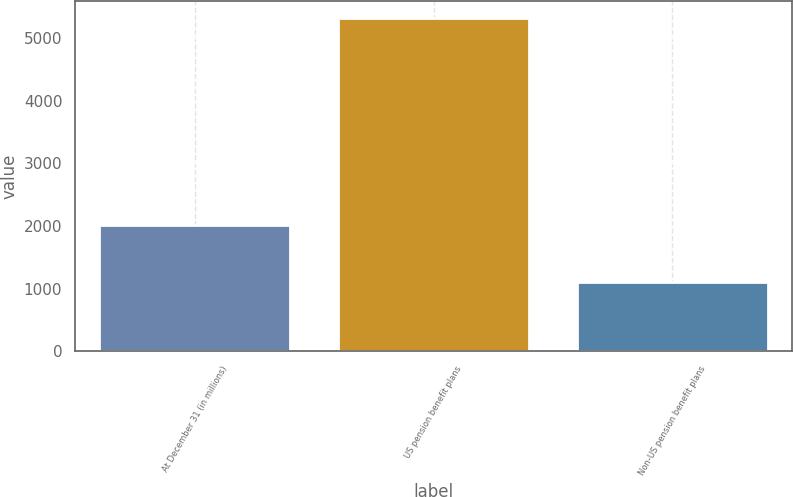Convert chart to OTSL. <chart><loc_0><loc_0><loc_500><loc_500><bar_chart><fcel>At December 31 (in millions)<fcel>US pension benefit plans<fcel>Non-US pension benefit plans<nl><fcel>2015<fcel>5324<fcel>1109<nl></chart> 